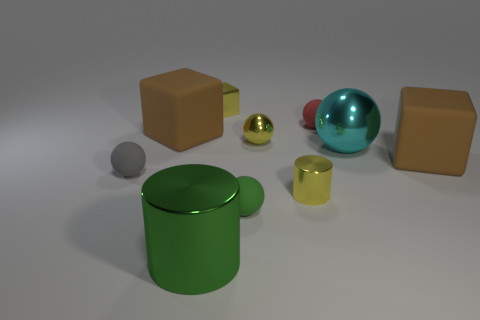Subtract all matte blocks. How many blocks are left? 1 Subtract all cyan spheres. How many brown cubes are left? 2 Subtract all cyan spheres. How many spheres are left? 4 Subtract all cylinders. How many objects are left? 8 Subtract 2 cylinders. How many cylinders are left? 0 Subtract all blue cylinders. Subtract all brown cubes. How many cylinders are left? 2 Subtract all small green matte balls. Subtract all tiny gray things. How many objects are left? 8 Add 7 large metal balls. How many large metal balls are left? 8 Add 3 big cyan metallic spheres. How many big cyan metallic spheres exist? 4 Subtract 0 brown balls. How many objects are left? 10 